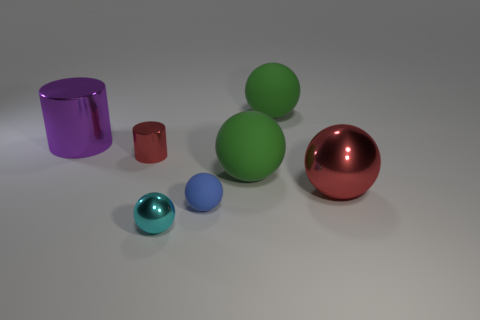Subtract all large balls. How many balls are left? 2 Add 3 purple objects. How many objects exist? 10 Subtract all green spheres. How many spheres are left? 3 Subtract all cylinders. How many objects are left? 5 Subtract 2 spheres. How many spheres are left? 3 Subtract all large green spheres. Subtract all blue balls. How many objects are left? 4 Add 6 small matte spheres. How many small matte spheres are left? 7 Add 2 tiny blue balls. How many tiny blue balls exist? 3 Subtract 1 red cylinders. How many objects are left? 6 Subtract all gray cylinders. Subtract all purple blocks. How many cylinders are left? 2 